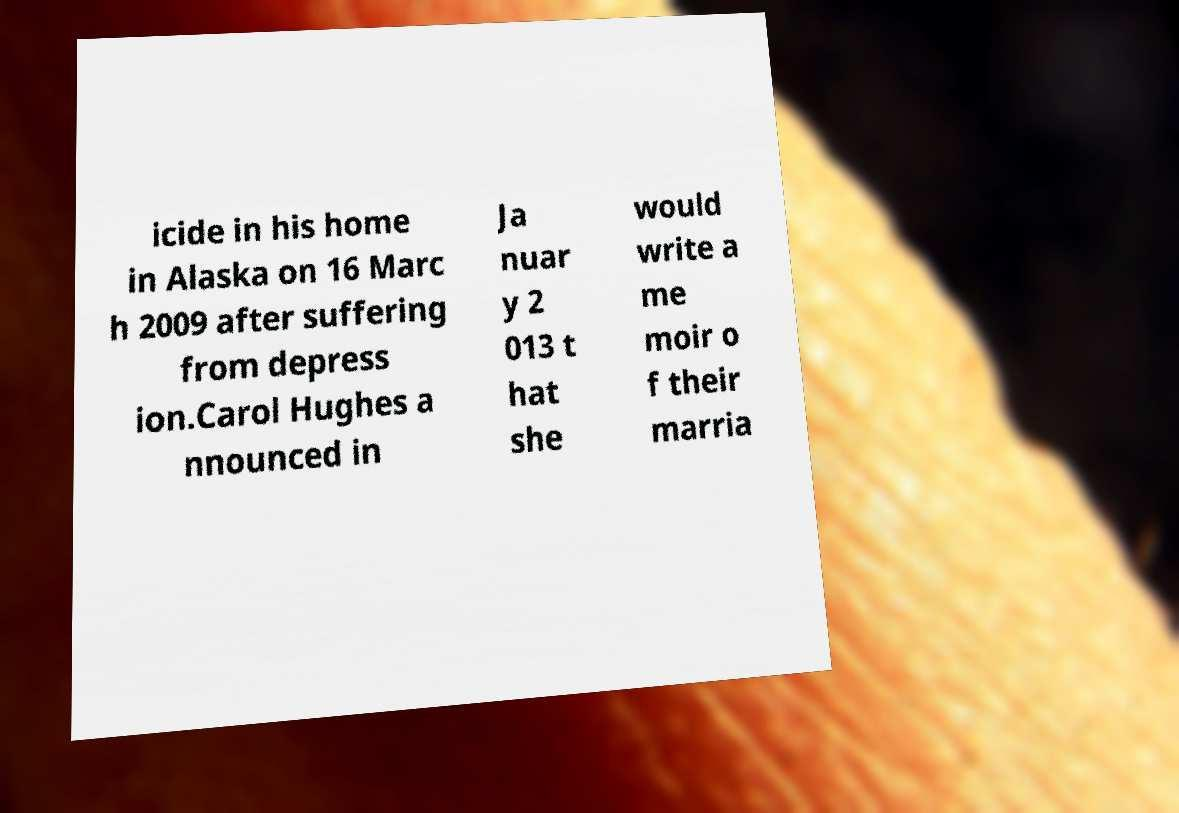Please read and relay the text visible in this image. What does it say? icide in his home in Alaska on 16 Marc h 2009 after suffering from depress ion.Carol Hughes a nnounced in Ja nuar y 2 013 t hat she would write a me moir o f their marria 